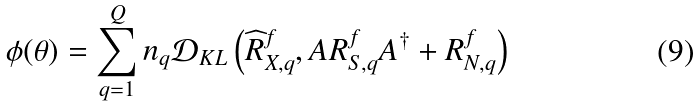Convert formula to latex. <formula><loc_0><loc_0><loc_500><loc_500>\phi ( \theta ) = \sum _ { q = 1 } ^ { Q } n _ { q } \mathcal { D } _ { K L } \left ( \widehat { R } _ { X , q } ^ { f } , A R _ { S , q } ^ { f } A ^ { \dagger } + R _ { N , q } ^ { f } \right )</formula> 